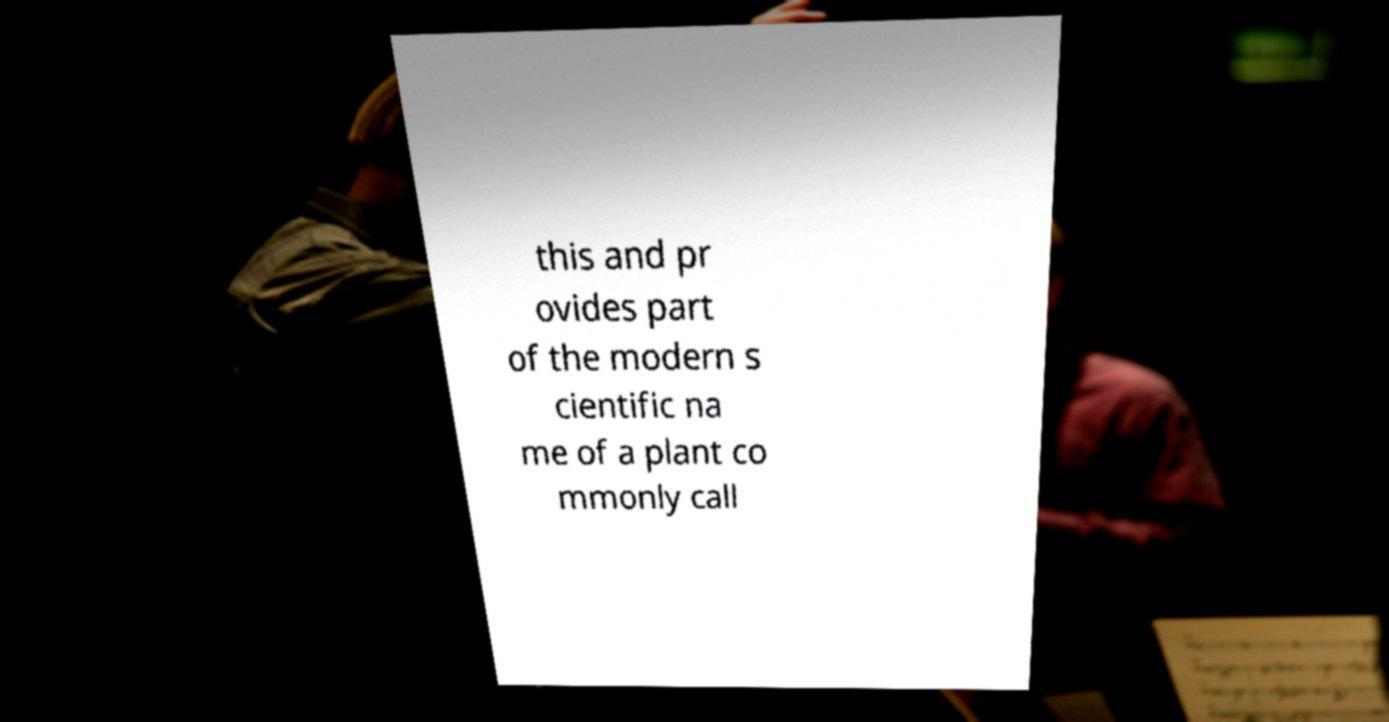For documentation purposes, I need the text within this image transcribed. Could you provide that? this and pr ovides part of the modern s cientific na me of a plant co mmonly call 